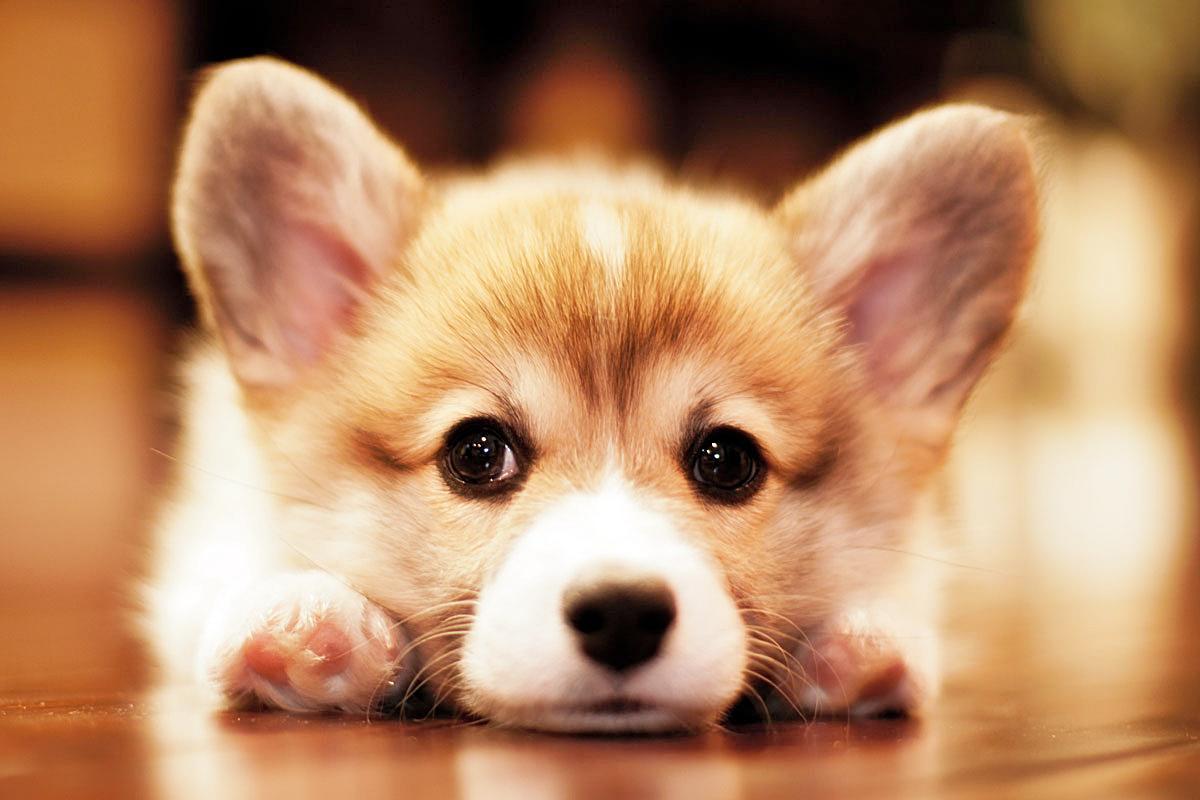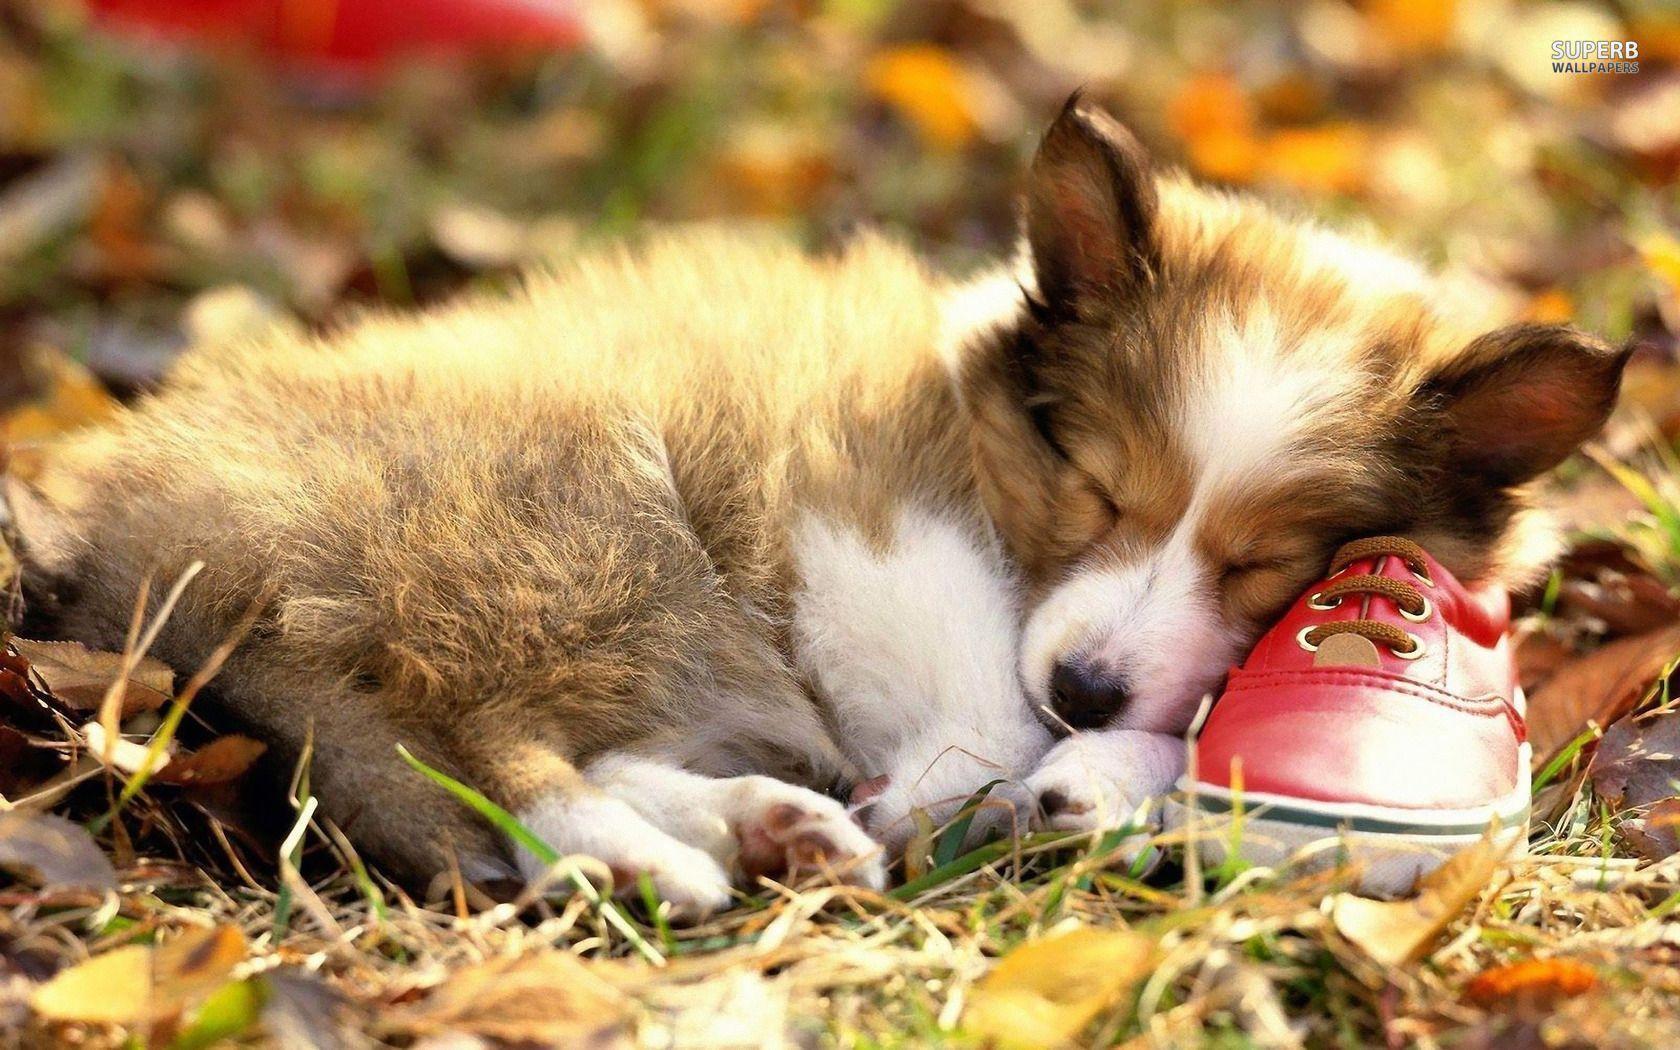The first image is the image on the left, the second image is the image on the right. Evaluate the accuracy of this statement regarding the images: "The right image contains exactly two dogs.". Is it true? Answer yes or no. No. The first image is the image on the left, the second image is the image on the right. Given the left and right images, does the statement "Two dogs are lying in the grass in the image on the right." hold true? Answer yes or no. No. 